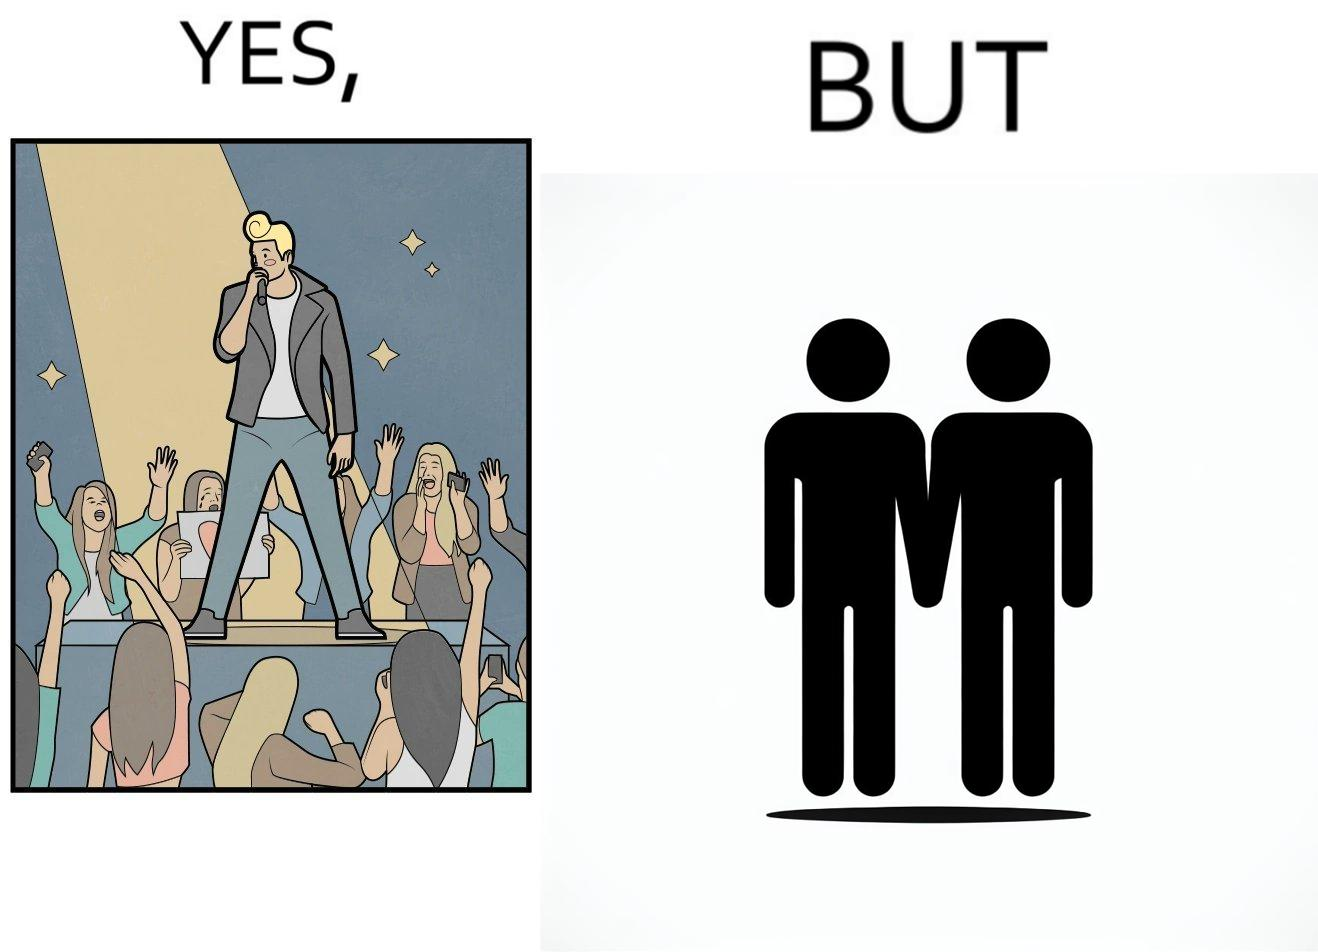What does this image depict? The image is funny because while the girls loves the man, he likes other men instead of women. 